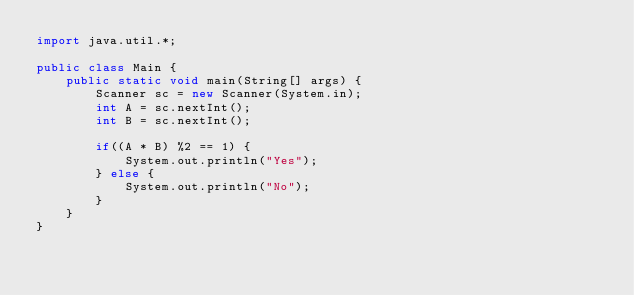<code> <loc_0><loc_0><loc_500><loc_500><_Java_>import java.util.*;

public class Main {
	public static void main(String[] args) {  
  		Scanner sc = new Scanner(System.in);
    	int A = sc.nextInt();
      	int B = sc.nextInt();
      
      	if((A * B) %2 == 1) {
        	System.out.println("Yes");
        } else {
          	System.out.println("No");
        }
    }
}</code> 